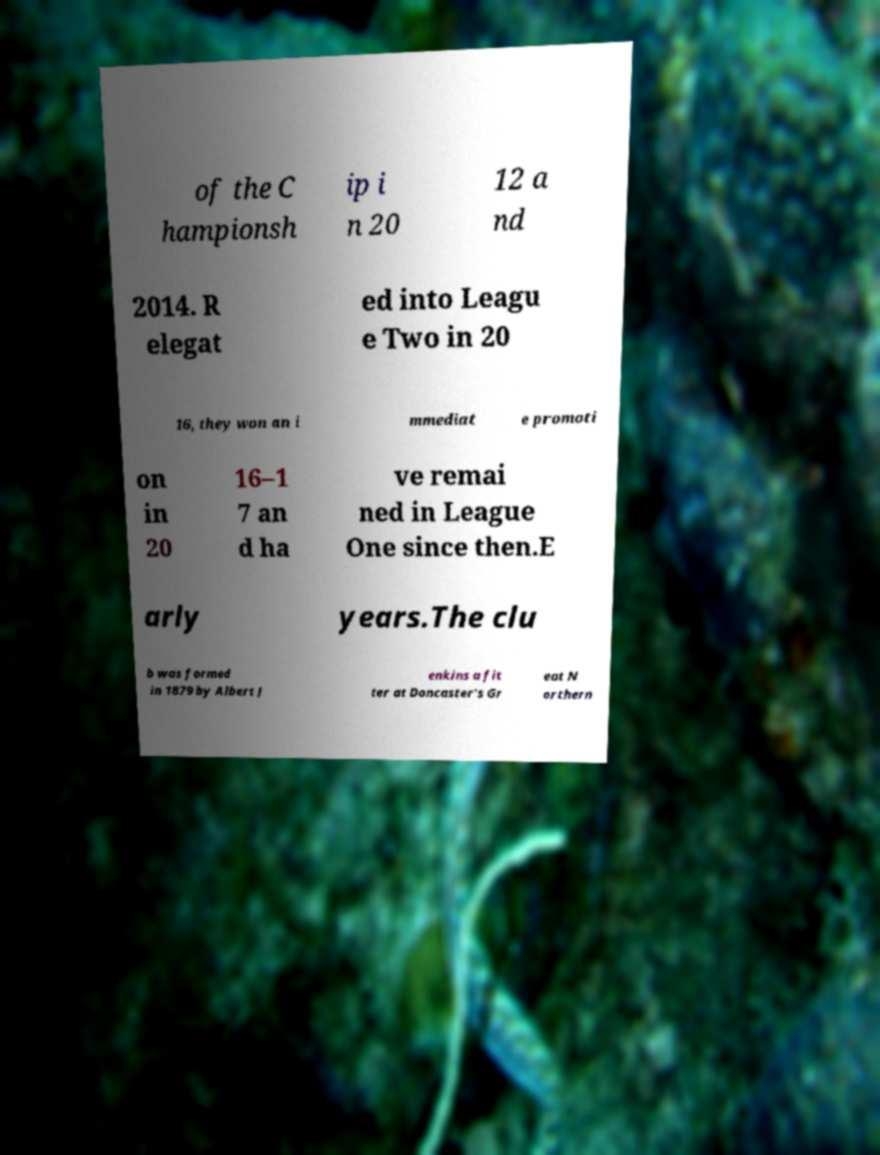Please read and relay the text visible in this image. What does it say? of the C hampionsh ip i n 20 12 a nd 2014. R elegat ed into Leagu e Two in 20 16, they won an i mmediat e promoti on in 20 16–1 7 an d ha ve remai ned in League One since then.E arly years.The clu b was formed in 1879 by Albert J enkins a fit ter at Doncaster's Gr eat N orthern 